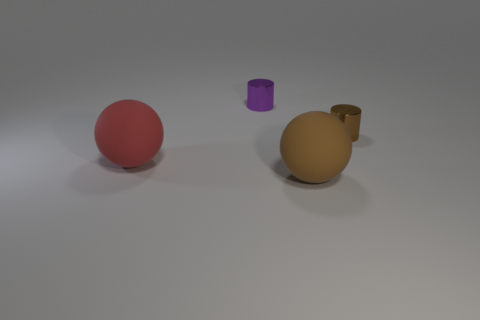The big ball in front of the big matte thing that is behind the large brown sphere is made of what material?
Offer a terse response. Rubber. There is a object that is made of the same material as the big brown sphere; what is its size?
Your response must be concise. Large. What shape is the brown thing that is to the left of the small brown object?
Provide a succinct answer. Sphere. The brown shiny object that is the same shape as the purple thing is what size?
Your answer should be very brief. Small. There is a tiny object behind the small cylinder in front of the purple metallic thing; what number of large red balls are on the right side of it?
Offer a very short reply. 0. Are there the same number of brown metal cylinders right of the brown cylinder and cyan matte cubes?
Your answer should be compact. Yes. How many cubes are big matte objects or small purple things?
Offer a terse response. 0. Are there the same number of tiny brown metal objects that are to the left of the tiny brown cylinder and small metal things that are left of the small purple metal cylinder?
Keep it short and to the point. Yes. What number of objects are brown things in front of the big red ball or small gray cubes?
Offer a terse response. 1. Do the cylinder right of the tiny purple shiny cylinder and the matte object behind the brown rubber sphere have the same size?
Offer a terse response. No. 